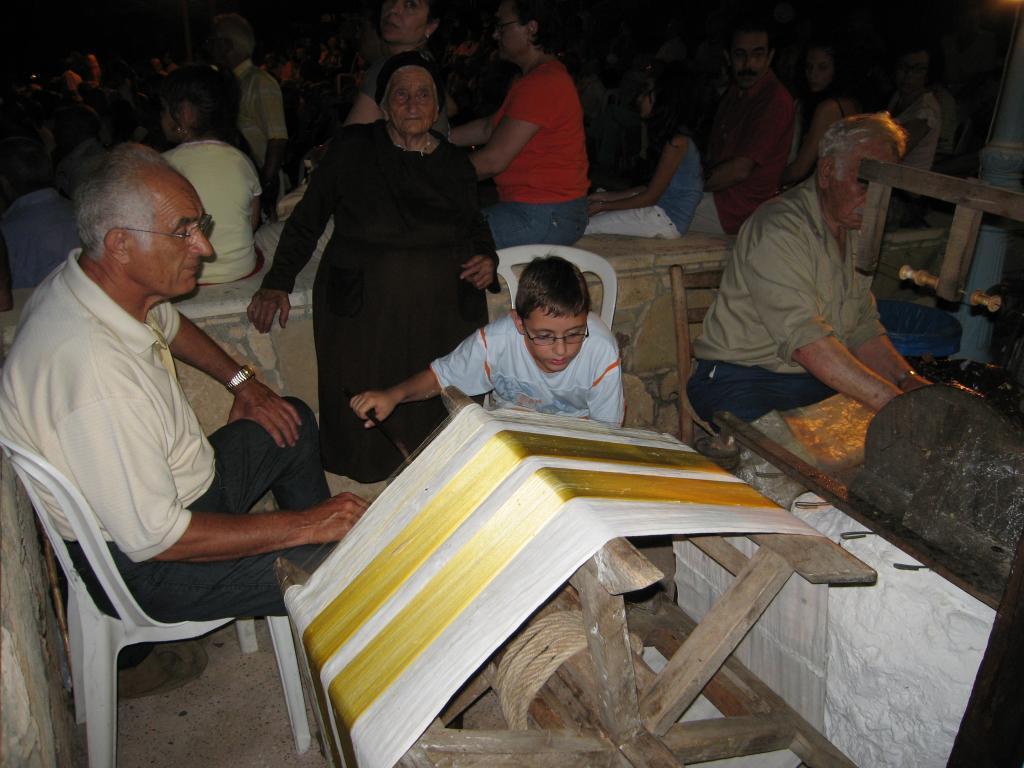Can you describe this image briefly? In the foreground we can see a cloth on a machine which is made with wood. We can also see a rope tied to it and some people sitting on the chairs. On the backside we can see a group of people and some children sitting on the surface. 